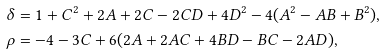<formula> <loc_0><loc_0><loc_500><loc_500>\delta & = 1 + C ^ { 2 } + 2 A + 2 C - 2 C D + 4 D ^ { 2 } - 4 ( A ^ { 2 } - A B + B ^ { 2 } ) , \\ \rho & = - 4 - 3 C + 6 ( 2 A + 2 A C + 4 B D - B C - 2 A D ) ,</formula> 